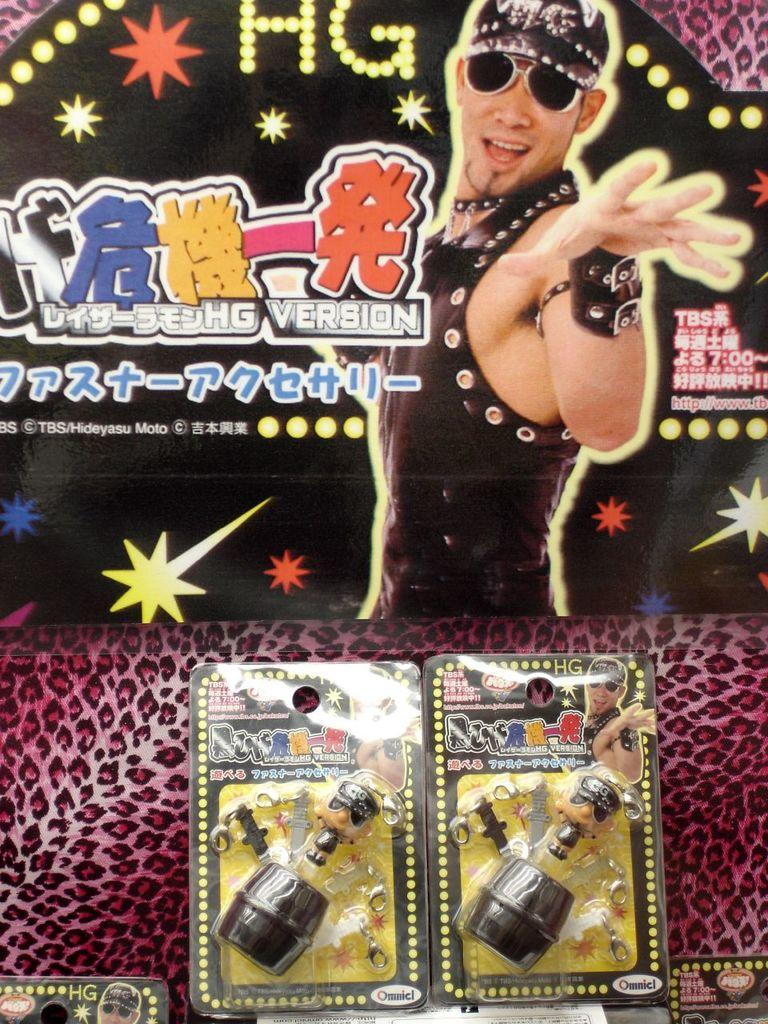What objects are placed on the surface in the image? There are toys placed on a surface in the image. What can be seen in the background of the image? There is a poster with a picture and text in the background of the image. What type of copper material is used to create the stage in the image? There is no stage or copper material present in the image. 